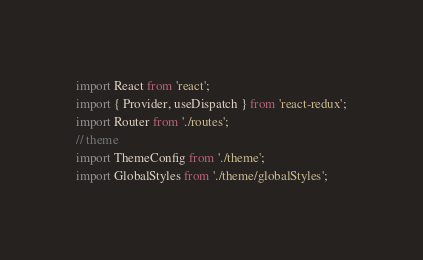<code> <loc_0><loc_0><loc_500><loc_500><_JavaScript_>import React from 'react';
import { Provider, useDispatch } from 'react-redux';
import Router from './routes';
// theme
import ThemeConfig from './theme';
import GlobalStyles from './theme/globalStyles';</code> 